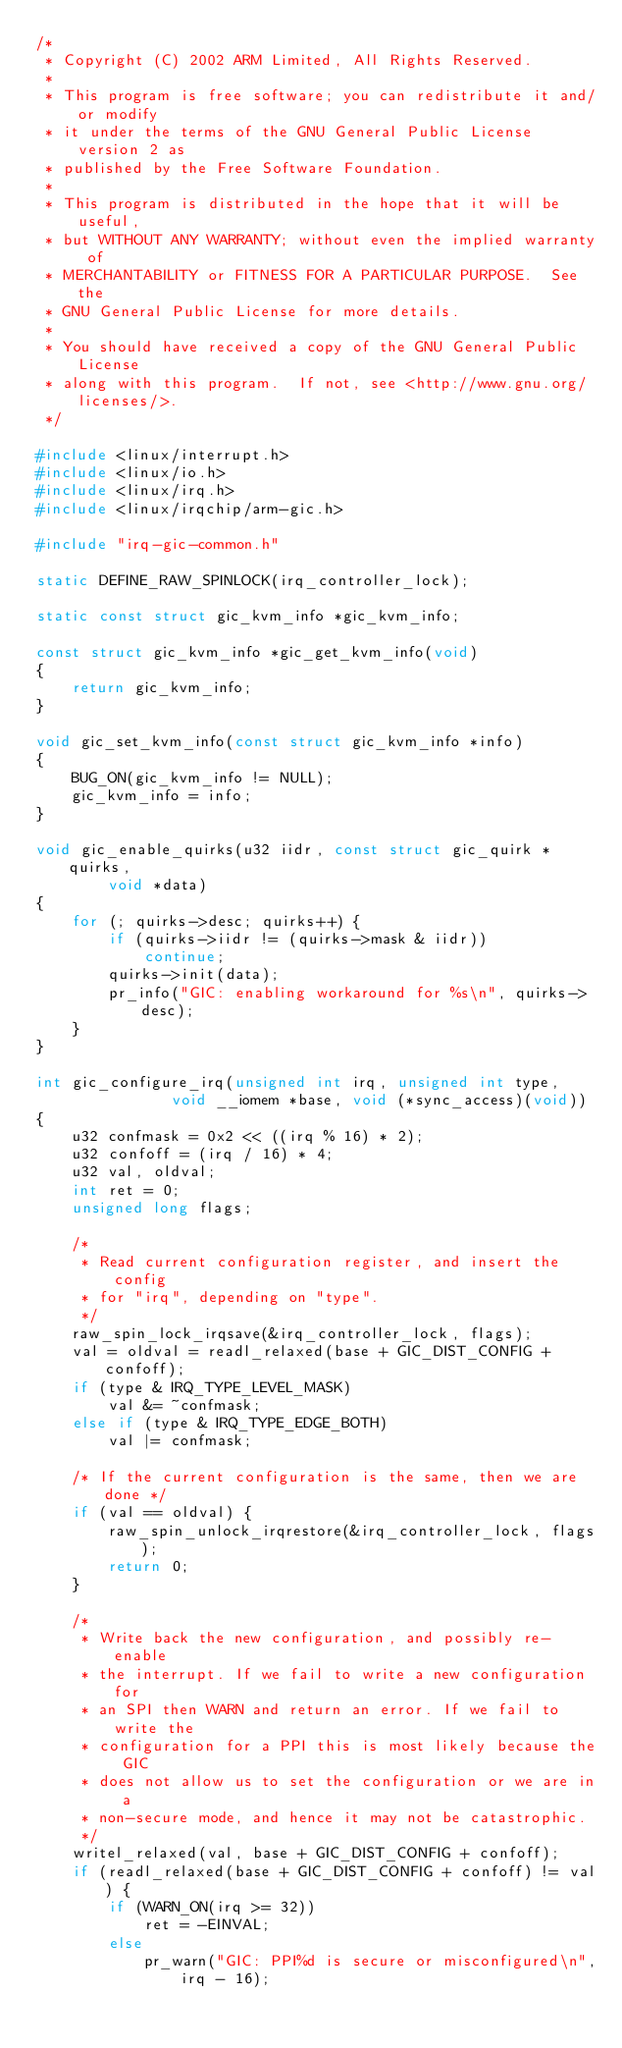Convert code to text. <code><loc_0><loc_0><loc_500><loc_500><_C_>/*
 * Copyright (C) 2002 ARM Limited, All Rights Reserved.
 *
 * This program is free software; you can redistribute it and/or modify
 * it under the terms of the GNU General Public License version 2 as
 * published by the Free Software Foundation.
 *
 * This program is distributed in the hope that it will be useful,
 * but WITHOUT ANY WARRANTY; without even the implied warranty of
 * MERCHANTABILITY or FITNESS FOR A PARTICULAR PURPOSE.  See the
 * GNU General Public License for more details.
 *
 * You should have received a copy of the GNU General Public License
 * along with this program.  If not, see <http://www.gnu.org/licenses/>.
 */

#include <linux/interrupt.h>
#include <linux/io.h>
#include <linux/irq.h>
#include <linux/irqchip/arm-gic.h>

#include "irq-gic-common.h"

static DEFINE_RAW_SPINLOCK(irq_controller_lock);

static const struct gic_kvm_info *gic_kvm_info;

const struct gic_kvm_info *gic_get_kvm_info(void)
{
	return gic_kvm_info;
}

void gic_set_kvm_info(const struct gic_kvm_info *info)
{
	BUG_ON(gic_kvm_info != NULL);
	gic_kvm_info = info;
}

void gic_enable_quirks(u32 iidr, const struct gic_quirk *quirks,
		void *data)
{
	for (; quirks->desc; quirks++) {
		if (quirks->iidr != (quirks->mask & iidr))
			continue;
		quirks->init(data);
		pr_info("GIC: enabling workaround for %s\n", quirks->desc);
	}
}

int gic_configure_irq(unsigned int irq, unsigned int type,
		       void __iomem *base, void (*sync_access)(void))
{
	u32 confmask = 0x2 << ((irq % 16) * 2);
	u32 confoff = (irq / 16) * 4;
	u32 val, oldval;
	int ret = 0;
	unsigned long flags;

	/*
	 * Read current configuration register, and insert the config
	 * for "irq", depending on "type".
	 */
	raw_spin_lock_irqsave(&irq_controller_lock, flags);
	val = oldval = readl_relaxed(base + GIC_DIST_CONFIG + confoff);
	if (type & IRQ_TYPE_LEVEL_MASK)
		val &= ~confmask;
	else if (type & IRQ_TYPE_EDGE_BOTH)
		val |= confmask;

	/* If the current configuration is the same, then we are done */
	if (val == oldval) {
		raw_spin_unlock_irqrestore(&irq_controller_lock, flags);
		return 0;
	}

	/*
	 * Write back the new configuration, and possibly re-enable
	 * the interrupt. If we fail to write a new configuration for
	 * an SPI then WARN and return an error. If we fail to write the
	 * configuration for a PPI this is most likely because the GIC
	 * does not allow us to set the configuration or we are in a
	 * non-secure mode, and hence it may not be catastrophic.
	 */
	writel_relaxed(val, base + GIC_DIST_CONFIG + confoff);
	if (readl_relaxed(base + GIC_DIST_CONFIG + confoff) != val) {
		if (WARN_ON(irq >= 32))
			ret = -EINVAL;
		else
			pr_warn("GIC: PPI%d is secure or misconfigured\n",
				irq - 16);</code> 